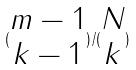Convert formula to latex. <formula><loc_0><loc_0><loc_500><loc_500>( \begin{matrix} m - 1 \\ k - 1 \end{matrix} ) / ( \begin{matrix} N \\ k \end{matrix} )</formula> 